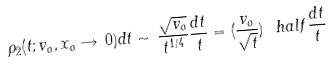Convert formula to latex. <formula><loc_0><loc_0><loc_500><loc_500>\rho _ { 2 } ( t ; v _ { o } , x _ { o } \rightarrow \, 0 ) d t \sim \, \frac { \sqrt { v _ { o } } } { t ^ { 1 / 4 } } \frac { d t } { t } = ( \frac { v _ { o } } { \sqrt { t } } ) ^ { \ } h a l f \frac { d t } { t }</formula> 